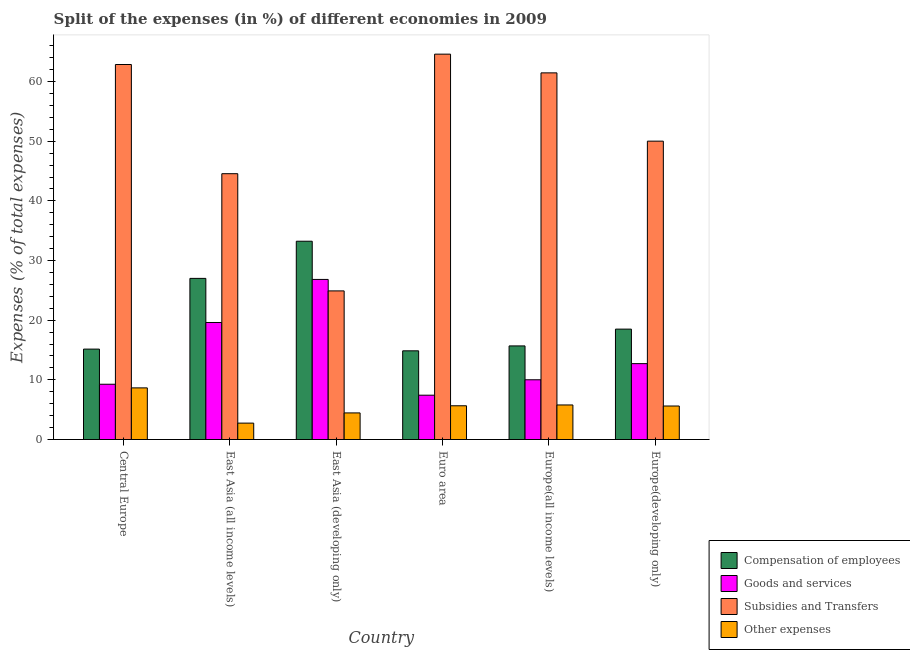How many bars are there on the 6th tick from the left?
Ensure brevity in your answer.  4. What is the label of the 4th group of bars from the left?
Provide a succinct answer. Euro area. What is the percentage of amount spent on goods and services in East Asia (all income levels)?
Your answer should be very brief. 19.62. Across all countries, what is the maximum percentage of amount spent on subsidies?
Offer a terse response. 64.59. Across all countries, what is the minimum percentage of amount spent on other expenses?
Offer a very short reply. 2.75. What is the total percentage of amount spent on other expenses in the graph?
Your response must be concise. 32.93. What is the difference between the percentage of amount spent on other expenses in Europe(all income levels) and that in Europe(developing only)?
Your answer should be very brief. 0.18. What is the difference between the percentage of amount spent on goods and services in Europe(all income levels) and the percentage of amount spent on other expenses in Europe(developing only)?
Give a very brief answer. 4.4. What is the average percentage of amount spent on subsidies per country?
Your answer should be very brief. 51.4. What is the difference between the percentage of amount spent on other expenses and percentage of amount spent on compensation of employees in East Asia (all income levels)?
Ensure brevity in your answer.  -24.26. In how many countries, is the percentage of amount spent on compensation of employees greater than 28 %?
Ensure brevity in your answer.  1. What is the ratio of the percentage of amount spent on goods and services in East Asia (all income levels) to that in Europe(developing only)?
Provide a short and direct response. 1.54. Is the percentage of amount spent on subsidies in East Asia (all income levels) less than that in Europe(developing only)?
Make the answer very short. Yes. What is the difference between the highest and the second highest percentage of amount spent on compensation of employees?
Offer a terse response. 6.23. What is the difference between the highest and the lowest percentage of amount spent on goods and services?
Your response must be concise. 19.41. In how many countries, is the percentage of amount spent on goods and services greater than the average percentage of amount spent on goods and services taken over all countries?
Offer a terse response. 2. What does the 3rd bar from the left in Central Europe represents?
Provide a succinct answer. Subsidies and Transfers. What does the 4th bar from the right in Central Europe represents?
Make the answer very short. Compensation of employees. Are all the bars in the graph horizontal?
Offer a terse response. No. How many countries are there in the graph?
Your answer should be compact. 6. What is the difference between two consecutive major ticks on the Y-axis?
Give a very brief answer. 10. Are the values on the major ticks of Y-axis written in scientific E-notation?
Offer a very short reply. No. Where does the legend appear in the graph?
Give a very brief answer. Bottom right. How many legend labels are there?
Offer a very short reply. 4. What is the title of the graph?
Provide a short and direct response. Split of the expenses (in %) of different economies in 2009. Does "Iceland" appear as one of the legend labels in the graph?
Your response must be concise. No. What is the label or title of the Y-axis?
Offer a terse response. Expenses (% of total expenses). What is the Expenses (% of total expenses) in Compensation of employees in Central Europe?
Your answer should be compact. 15.16. What is the Expenses (% of total expenses) in Goods and services in Central Europe?
Keep it short and to the point. 9.27. What is the Expenses (% of total expenses) in Subsidies and Transfers in Central Europe?
Give a very brief answer. 62.86. What is the Expenses (% of total expenses) of Other expenses in Central Europe?
Keep it short and to the point. 8.65. What is the Expenses (% of total expenses) in Compensation of employees in East Asia (all income levels)?
Provide a short and direct response. 27.01. What is the Expenses (% of total expenses) of Goods and services in East Asia (all income levels)?
Ensure brevity in your answer.  19.62. What is the Expenses (% of total expenses) of Subsidies and Transfers in East Asia (all income levels)?
Offer a very short reply. 44.56. What is the Expenses (% of total expenses) of Other expenses in East Asia (all income levels)?
Offer a terse response. 2.75. What is the Expenses (% of total expenses) of Compensation of employees in East Asia (developing only)?
Keep it short and to the point. 33.24. What is the Expenses (% of total expenses) of Goods and services in East Asia (developing only)?
Make the answer very short. 26.83. What is the Expenses (% of total expenses) of Subsidies and Transfers in East Asia (developing only)?
Keep it short and to the point. 24.91. What is the Expenses (% of total expenses) of Other expenses in East Asia (developing only)?
Ensure brevity in your answer.  4.46. What is the Expenses (% of total expenses) of Compensation of employees in Euro area?
Your response must be concise. 14.87. What is the Expenses (% of total expenses) of Goods and services in Euro area?
Offer a terse response. 7.43. What is the Expenses (% of total expenses) of Subsidies and Transfers in Euro area?
Offer a terse response. 64.59. What is the Expenses (% of total expenses) of Other expenses in Euro area?
Offer a terse response. 5.66. What is the Expenses (% of total expenses) in Compensation of employees in Europe(all income levels)?
Keep it short and to the point. 15.69. What is the Expenses (% of total expenses) in Goods and services in Europe(all income levels)?
Keep it short and to the point. 10.01. What is the Expenses (% of total expenses) in Subsidies and Transfers in Europe(all income levels)?
Offer a very short reply. 61.46. What is the Expenses (% of total expenses) in Other expenses in Europe(all income levels)?
Ensure brevity in your answer.  5.79. What is the Expenses (% of total expenses) in Compensation of employees in Europe(developing only)?
Your answer should be very brief. 18.5. What is the Expenses (% of total expenses) of Goods and services in Europe(developing only)?
Your answer should be very brief. 12.72. What is the Expenses (% of total expenses) in Subsidies and Transfers in Europe(developing only)?
Offer a terse response. 50.01. What is the Expenses (% of total expenses) of Other expenses in Europe(developing only)?
Ensure brevity in your answer.  5.62. Across all countries, what is the maximum Expenses (% of total expenses) of Compensation of employees?
Your answer should be compact. 33.24. Across all countries, what is the maximum Expenses (% of total expenses) in Goods and services?
Your answer should be very brief. 26.83. Across all countries, what is the maximum Expenses (% of total expenses) in Subsidies and Transfers?
Offer a terse response. 64.59. Across all countries, what is the maximum Expenses (% of total expenses) of Other expenses?
Provide a short and direct response. 8.65. Across all countries, what is the minimum Expenses (% of total expenses) of Compensation of employees?
Make the answer very short. 14.87. Across all countries, what is the minimum Expenses (% of total expenses) in Goods and services?
Give a very brief answer. 7.43. Across all countries, what is the minimum Expenses (% of total expenses) in Subsidies and Transfers?
Provide a short and direct response. 24.91. Across all countries, what is the minimum Expenses (% of total expenses) in Other expenses?
Give a very brief answer. 2.75. What is the total Expenses (% of total expenses) in Compensation of employees in the graph?
Your answer should be very brief. 124.46. What is the total Expenses (% of total expenses) in Goods and services in the graph?
Your response must be concise. 85.88. What is the total Expenses (% of total expenses) of Subsidies and Transfers in the graph?
Keep it short and to the point. 308.39. What is the total Expenses (% of total expenses) in Other expenses in the graph?
Give a very brief answer. 32.93. What is the difference between the Expenses (% of total expenses) in Compensation of employees in Central Europe and that in East Asia (all income levels)?
Provide a succinct answer. -11.85. What is the difference between the Expenses (% of total expenses) of Goods and services in Central Europe and that in East Asia (all income levels)?
Give a very brief answer. -10.35. What is the difference between the Expenses (% of total expenses) of Subsidies and Transfers in Central Europe and that in East Asia (all income levels)?
Ensure brevity in your answer.  18.3. What is the difference between the Expenses (% of total expenses) in Other expenses in Central Europe and that in East Asia (all income levels)?
Your response must be concise. 5.91. What is the difference between the Expenses (% of total expenses) of Compensation of employees in Central Europe and that in East Asia (developing only)?
Offer a very short reply. -18.08. What is the difference between the Expenses (% of total expenses) of Goods and services in Central Europe and that in East Asia (developing only)?
Make the answer very short. -17.57. What is the difference between the Expenses (% of total expenses) of Subsidies and Transfers in Central Europe and that in East Asia (developing only)?
Offer a terse response. 37.95. What is the difference between the Expenses (% of total expenses) in Other expenses in Central Europe and that in East Asia (developing only)?
Your response must be concise. 4.2. What is the difference between the Expenses (% of total expenses) in Compensation of employees in Central Europe and that in Euro area?
Provide a short and direct response. 0.29. What is the difference between the Expenses (% of total expenses) in Goods and services in Central Europe and that in Euro area?
Make the answer very short. 1.84. What is the difference between the Expenses (% of total expenses) in Subsidies and Transfers in Central Europe and that in Euro area?
Provide a succinct answer. -1.74. What is the difference between the Expenses (% of total expenses) of Other expenses in Central Europe and that in Euro area?
Keep it short and to the point. 3. What is the difference between the Expenses (% of total expenses) in Compensation of employees in Central Europe and that in Europe(all income levels)?
Your answer should be compact. -0.53. What is the difference between the Expenses (% of total expenses) in Goods and services in Central Europe and that in Europe(all income levels)?
Offer a very short reply. -0.75. What is the difference between the Expenses (% of total expenses) of Subsidies and Transfers in Central Europe and that in Europe(all income levels)?
Your answer should be very brief. 1.4. What is the difference between the Expenses (% of total expenses) in Other expenses in Central Europe and that in Europe(all income levels)?
Offer a terse response. 2.86. What is the difference between the Expenses (% of total expenses) of Compensation of employees in Central Europe and that in Europe(developing only)?
Ensure brevity in your answer.  -3.35. What is the difference between the Expenses (% of total expenses) of Goods and services in Central Europe and that in Europe(developing only)?
Provide a short and direct response. -3.45. What is the difference between the Expenses (% of total expenses) in Subsidies and Transfers in Central Europe and that in Europe(developing only)?
Provide a succinct answer. 12.85. What is the difference between the Expenses (% of total expenses) in Other expenses in Central Europe and that in Europe(developing only)?
Your response must be concise. 3.04. What is the difference between the Expenses (% of total expenses) of Compensation of employees in East Asia (all income levels) and that in East Asia (developing only)?
Offer a terse response. -6.23. What is the difference between the Expenses (% of total expenses) of Goods and services in East Asia (all income levels) and that in East Asia (developing only)?
Provide a succinct answer. -7.22. What is the difference between the Expenses (% of total expenses) of Subsidies and Transfers in East Asia (all income levels) and that in East Asia (developing only)?
Keep it short and to the point. 19.65. What is the difference between the Expenses (% of total expenses) in Other expenses in East Asia (all income levels) and that in East Asia (developing only)?
Make the answer very short. -1.71. What is the difference between the Expenses (% of total expenses) in Compensation of employees in East Asia (all income levels) and that in Euro area?
Give a very brief answer. 12.14. What is the difference between the Expenses (% of total expenses) of Goods and services in East Asia (all income levels) and that in Euro area?
Your answer should be compact. 12.19. What is the difference between the Expenses (% of total expenses) of Subsidies and Transfers in East Asia (all income levels) and that in Euro area?
Give a very brief answer. -20.04. What is the difference between the Expenses (% of total expenses) of Other expenses in East Asia (all income levels) and that in Euro area?
Your answer should be compact. -2.91. What is the difference between the Expenses (% of total expenses) of Compensation of employees in East Asia (all income levels) and that in Europe(all income levels)?
Offer a terse response. 11.32. What is the difference between the Expenses (% of total expenses) of Goods and services in East Asia (all income levels) and that in Europe(all income levels)?
Make the answer very short. 9.6. What is the difference between the Expenses (% of total expenses) of Subsidies and Transfers in East Asia (all income levels) and that in Europe(all income levels)?
Give a very brief answer. -16.9. What is the difference between the Expenses (% of total expenses) in Other expenses in East Asia (all income levels) and that in Europe(all income levels)?
Keep it short and to the point. -3.04. What is the difference between the Expenses (% of total expenses) of Compensation of employees in East Asia (all income levels) and that in Europe(developing only)?
Keep it short and to the point. 8.51. What is the difference between the Expenses (% of total expenses) of Goods and services in East Asia (all income levels) and that in Europe(developing only)?
Give a very brief answer. 6.9. What is the difference between the Expenses (% of total expenses) of Subsidies and Transfers in East Asia (all income levels) and that in Europe(developing only)?
Ensure brevity in your answer.  -5.45. What is the difference between the Expenses (% of total expenses) in Other expenses in East Asia (all income levels) and that in Europe(developing only)?
Ensure brevity in your answer.  -2.87. What is the difference between the Expenses (% of total expenses) of Compensation of employees in East Asia (developing only) and that in Euro area?
Offer a very short reply. 18.37. What is the difference between the Expenses (% of total expenses) of Goods and services in East Asia (developing only) and that in Euro area?
Your response must be concise. 19.41. What is the difference between the Expenses (% of total expenses) of Subsidies and Transfers in East Asia (developing only) and that in Euro area?
Your response must be concise. -39.68. What is the difference between the Expenses (% of total expenses) in Other expenses in East Asia (developing only) and that in Euro area?
Provide a succinct answer. -1.2. What is the difference between the Expenses (% of total expenses) in Compensation of employees in East Asia (developing only) and that in Europe(all income levels)?
Provide a short and direct response. 17.55. What is the difference between the Expenses (% of total expenses) in Goods and services in East Asia (developing only) and that in Europe(all income levels)?
Provide a short and direct response. 16.82. What is the difference between the Expenses (% of total expenses) in Subsidies and Transfers in East Asia (developing only) and that in Europe(all income levels)?
Give a very brief answer. -36.55. What is the difference between the Expenses (% of total expenses) of Other expenses in East Asia (developing only) and that in Europe(all income levels)?
Make the answer very short. -1.33. What is the difference between the Expenses (% of total expenses) in Compensation of employees in East Asia (developing only) and that in Europe(developing only)?
Your answer should be very brief. 14.73. What is the difference between the Expenses (% of total expenses) of Goods and services in East Asia (developing only) and that in Europe(developing only)?
Ensure brevity in your answer.  14.12. What is the difference between the Expenses (% of total expenses) of Subsidies and Transfers in East Asia (developing only) and that in Europe(developing only)?
Make the answer very short. -25.1. What is the difference between the Expenses (% of total expenses) in Other expenses in East Asia (developing only) and that in Europe(developing only)?
Provide a succinct answer. -1.16. What is the difference between the Expenses (% of total expenses) of Compensation of employees in Euro area and that in Europe(all income levels)?
Offer a very short reply. -0.82. What is the difference between the Expenses (% of total expenses) in Goods and services in Euro area and that in Europe(all income levels)?
Offer a very short reply. -2.59. What is the difference between the Expenses (% of total expenses) in Subsidies and Transfers in Euro area and that in Europe(all income levels)?
Provide a succinct answer. 3.14. What is the difference between the Expenses (% of total expenses) of Other expenses in Euro area and that in Europe(all income levels)?
Your answer should be compact. -0.14. What is the difference between the Expenses (% of total expenses) of Compensation of employees in Euro area and that in Europe(developing only)?
Offer a terse response. -3.64. What is the difference between the Expenses (% of total expenses) in Goods and services in Euro area and that in Europe(developing only)?
Your answer should be very brief. -5.29. What is the difference between the Expenses (% of total expenses) in Subsidies and Transfers in Euro area and that in Europe(developing only)?
Make the answer very short. 14.58. What is the difference between the Expenses (% of total expenses) in Other expenses in Euro area and that in Europe(developing only)?
Your answer should be very brief. 0.04. What is the difference between the Expenses (% of total expenses) in Compensation of employees in Europe(all income levels) and that in Europe(developing only)?
Provide a short and direct response. -2.81. What is the difference between the Expenses (% of total expenses) in Goods and services in Europe(all income levels) and that in Europe(developing only)?
Keep it short and to the point. -2.7. What is the difference between the Expenses (% of total expenses) of Subsidies and Transfers in Europe(all income levels) and that in Europe(developing only)?
Your response must be concise. 11.44. What is the difference between the Expenses (% of total expenses) in Other expenses in Europe(all income levels) and that in Europe(developing only)?
Provide a succinct answer. 0.18. What is the difference between the Expenses (% of total expenses) in Compensation of employees in Central Europe and the Expenses (% of total expenses) in Goods and services in East Asia (all income levels)?
Make the answer very short. -4.46. What is the difference between the Expenses (% of total expenses) of Compensation of employees in Central Europe and the Expenses (% of total expenses) of Subsidies and Transfers in East Asia (all income levels)?
Give a very brief answer. -29.4. What is the difference between the Expenses (% of total expenses) of Compensation of employees in Central Europe and the Expenses (% of total expenses) of Other expenses in East Asia (all income levels)?
Ensure brevity in your answer.  12.41. What is the difference between the Expenses (% of total expenses) of Goods and services in Central Europe and the Expenses (% of total expenses) of Subsidies and Transfers in East Asia (all income levels)?
Your response must be concise. -35.29. What is the difference between the Expenses (% of total expenses) of Goods and services in Central Europe and the Expenses (% of total expenses) of Other expenses in East Asia (all income levels)?
Offer a very short reply. 6.52. What is the difference between the Expenses (% of total expenses) of Subsidies and Transfers in Central Europe and the Expenses (% of total expenses) of Other expenses in East Asia (all income levels)?
Ensure brevity in your answer.  60.11. What is the difference between the Expenses (% of total expenses) of Compensation of employees in Central Europe and the Expenses (% of total expenses) of Goods and services in East Asia (developing only)?
Your answer should be compact. -11.68. What is the difference between the Expenses (% of total expenses) in Compensation of employees in Central Europe and the Expenses (% of total expenses) in Subsidies and Transfers in East Asia (developing only)?
Provide a short and direct response. -9.75. What is the difference between the Expenses (% of total expenses) of Compensation of employees in Central Europe and the Expenses (% of total expenses) of Other expenses in East Asia (developing only)?
Provide a short and direct response. 10.7. What is the difference between the Expenses (% of total expenses) in Goods and services in Central Europe and the Expenses (% of total expenses) in Subsidies and Transfers in East Asia (developing only)?
Provide a succinct answer. -15.64. What is the difference between the Expenses (% of total expenses) in Goods and services in Central Europe and the Expenses (% of total expenses) in Other expenses in East Asia (developing only)?
Offer a very short reply. 4.81. What is the difference between the Expenses (% of total expenses) in Subsidies and Transfers in Central Europe and the Expenses (% of total expenses) in Other expenses in East Asia (developing only)?
Your answer should be compact. 58.4. What is the difference between the Expenses (% of total expenses) of Compensation of employees in Central Europe and the Expenses (% of total expenses) of Goods and services in Euro area?
Provide a short and direct response. 7.73. What is the difference between the Expenses (% of total expenses) in Compensation of employees in Central Europe and the Expenses (% of total expenses) in Subsidies and Transfers in Euro area?
Give a very brief answer. -49.44. What is the difference between the Expenses (% of total expenses) in Compensation of employees in Central Europe and the Expenses (% of total expenses) in Other expenses in Euro area?
Your response must be concise. 9.5. What is the difference between the Expenses (% of total expenses) in Goods and services in Central Europe and the Expenses (% of total expenses) in Subsidies and Transfers in Euro area?
Your answer should be compact. -55.33. What is the difference between the Expenses (% of total expenses) in Goods and services in Central Europe and the Expenses (% of total expenses) in Other expenses in Euro area?
Your answer should be very brief. 3.61. What is the difference between the Expenses (% of total expenses) of Subsidies and Transfers in Central Europe and the Expenses (% of total expenses) of Other expenses in Euro area?
Provide a short and direct response. 57.2. What is the difference between the Expenses (% of total expenses) in Compensation of employees in Central Europe and the Expenses (% of total expenses) in Goods and services in Europe(all income levels)?
Give a very brief answer. 5.14. What is the difference between the Expenses (% of total expenses) of Compensation of employees in Central Europe and the Expenses (% of total expenses) of Subsidies and Transfers in Europe(all income levels)?
Give a very brief answer. -46.3. What is the difference between the Expenses (% of total expenses) of Compensation of employees in Central Europe and the Expenses (% of total expenses) of Other expenses in Europe(all income levels)?
Ensure brevity in your answer.  9.36. What is the difference between the Expenses (% of total expenses) in Goods and services in Central Europe and the Expenses (% of total expenses) in Subsidies and Transfers in Europe(all income levels)?
Offer a very short reply. -52.19. What is the difference between the Expenses (% of total expenses) in Goods and services in Central Europe and the Expenses (% of total expenses) in Other expenses in Europe(all income levels)?
Your answer should be very brief. 3.47. What is the difference between the Expenses (% of total expenses) in Subsidies and Transfers in Central Europe and the Expenses (% of total expenses) in Other expenses in Europe(all income levels)?
Offer a terse response. 57.06. What is the difference between the Expenses (% of total expenses) in Compensation of employees in Central Europe and the Expenses (% of total expenses) in Goods and services in Europe(developing only)?
Keep it short and to the point. 2.44. What is the difference between the Expenses (% of total expenses) in Compensation of employees in Central Europe and the Expenses (% of total expenses) in Subsidies and Transfers in Europe(developing only)?
Provide a succinct answer. -34.86. What is the difference between the Expenses (% of total expenses) of Compensation of employees in Central Europe and the Expenses (% of total expenses) of Other expenses in Europe(developing only)?
Offer a very short reply. 9.54. What is the difference between the Expenses (% of total expenses) of Goods and services in Central Europe and the Expenses (% of total expenses) of Subsidies and Transfers in Europe(developing only)?
Provide a succinct answer. -40.74. What is the difference between the Expenses (% of total expenses) in Goods and services in Central Europe and the Expenses (% of total expenses) in Other expenses in Europe(developing only)?
Offer a terse response. 3.65. What is the difference between the Expenses (% of total expenses) of Subsidies and Transfers in Central Europe and the Expenses (% of total expenses) of Other expenses in Europe(developing only)?
Offer a terse response. 57.24. What is the difference between the Expenses (% of total expenses) of Compensation of employees in East Asia (all income levels) and the Expenses (% of total expenses) of Goods and services in East Asia (developing only)?
Make the answer very short. 0.17. What is the difference between the Expenses (% of total expenses) in Compensation of employees in East Asia (all income levels) and the Expenses (% of total expenses) in Subsidies and Transfers in East Asia (developing only)?
Your answer should be very brief. 2.1. What is the difference between the Expenses (% of total expenses) in Compensation of employees in East Asia (all income levels) and the Expenses (% of total expenses) in Other expenses in East Asia (developing only)?
Offer a terse response. 22.55. What is the difference between the Expenses (% of total expenses) in Goods and services in East Asia (all income levels) and the Expenses (% of total expenses) in Subsidies and Transfers in East Asia (developing only)?
Provide a short and direct response. -5.29. What is the difference between the Expenses (% of total expenses) in Goods and services in East Asia (all income levels) and the Expenses (% of total expenses) in Other expenses in East Asia (developing only)?
Offer a terse response. 15.16. What is the difference between the Expenses (% of total expenses) of Subsidies and Transfers in East Asia (all income levels) and the Expenses (% of total expenses) of Other expenses in East Asia (developing only)?
Offer a terse response. 40.1. What is the difference between the Expenses (% of total expenses) of Compensation of employees in East Asia (all income levels) and the Expenses (% of total expenses) of Goods and services in Euro area?
Offer a very short reply. 19.58. What is the difference between the Expenses (% of total expenses) of Compensation of employees in East Asia (all income levels) and the Expenses (% of total expenses) of Subsidies and Transfers in Euro area?
Keep it short and to the point. -37.58. What is the difference between the Expenses (% of total expenses) of Compensation of employees in East Asia (all income levels) and the Expenses (% of total expenses) of Other expenses in Euro area?
Keep it short and to the point. 21.35. What is the difference between the Expenses (% of total expenses) of Goods and services in East Asia (all income levels) and the Expenses (% of total expenses) of Subsidies and Transfers in Euro area?
Provide a short and direct response. -44.98. What is the difference between the Expenses (% of total expenses) in Goods and services in East Asia (all income levels) and the Expenses (% of total expenses) in Other expenses in Euro area?
Provide a succinct answer. 13.96. What is the difference between the Expenses (% of total expenses) in Subsidies and Transfers in East Asia (all income levels) and the Expenses (% of total expenses) in Other expenses in Euro area?
Provide a short and direct response. 38.9. What is the difference between the Expenses (% of total expenses) of Compensation of employees in East Asia (all income levels) and the Expenses (% of total expenses) of Goods and services in Europe(all income levels)?
Give a very brief answer. 16.99. What is the difference between the Expenses (% of total expenses) in Compensation of employees in East Asia (all income levels) and the Expenses (% of total expenses) in Subsidies and Transfers in Europe(all income levels)?
Offer a terse response. -34.45. What is the difference between the Expenses (% of total expenses) in Compensation of employees in East Asia (all income levels) and the Expenses (% of total expenses) in Other expenses in Europe(all income levels)?
Your answer should be very brief. 21.22. What is the difference between the Expenses (% of total expenses) in Goods and services in East Asia (all income levels) and the Expenses (% of total expenses) in Subsidies and Transfers in Europe(all income levels)?
Make the answer very short. -41.84. What is the difference between the Expenses (% of total expenses) of Goods and services in East Asia (all income levels) and the Expenses (% of total expenses) of Other expenses in Europe(all income levels)?
Keep it short and to the point. 13.82. What is the difference between the Expenses (% of total expenses) of Subsidies and Transfers in East Asia (all income levels) and the Expenses (% of total expenses) of Other expenses in Europe(all income levels)?
Your answer should be compact. 38.76. What is the difference between the Expenses (% of total expenses) of Compensation of employees in East Asia (all income levels) and the Expenses (% of total expenses) of Goods and services in Europe(developing only)?
Your answer should be compact. 14.29. What is the difference between the Expenses (% of total expenses) of Compensation of employees in East Asia (all income levels) and the Expenses (% of total expenses) of Subsidies and Transfers in Europe(developing only)?
Your answer should be very brief. -23. What is the difference between the Expenses (% of total expenses) in Compensation of employees in East Asia (all income levels) and the Expenses (% of total expenses) in Other expenses in Europe(developing only)?
Provide a short and direct response. 21.39. What is the difference between the Expenses (% of total expenses) in Goods and services in East Asia (all income levels) and the Expenses (% of total expenses) in Subsidies and Transfers in Europe(developing only)?
Offer a terse response. -30.4. What is the difference between the Expenses (% of total expenses) in Goods and services in East Asia (all income levels) and the Expenses (% of total expenses) in Other expenses in Europe(developing only)?
Offer a terse response. 14. What is the difference between the Expenses (% of total expenses) of Subsidies and Transfers in East Asia (all income levels) and the Expenses (% of total expenses) of Other expenses in Europe(developing only)?
Give a very brief answer. 38.94. What is the difference between the Expenses (% of total expenses) of Compensation of employees in East Asia (developing only) and the Expenses (% of total expenses) of Goods and services in Euro area?
Provide a succinct answer. 25.81. What is the difference between the Expenses (% of total expenses) in Compensation of employees in East Asia (developing only) and the Expenses (% of total expenses) in Subsidies and Transfers in Euro area?
Give a very brief answer. -31.36. What is the difference between the Expenses (% of total expenses) of Compensation of employees in East Asia (developing only) and the Expenses (% of total expenses) of Other expenses in Euro area?
Your answer should be very brief. 27.58. What is the difference between the Expenses (% of total expenses) in Goods and services in East Asia (developing only) and the Expenses (% of total expenses) in Subsidies and Transfers in Euro area?
Your response must be concise. -37.76. What is the difference between the Expenses (% of total expenses) of Goods and services in East Asia (developing only) and the Expenses (% of total expenses) of Other expenses in Euro area?
Provide a succinct answer. 21.18. What is the difference between the Expenses (% of total expenses) in Subsidies and Transfers in East Asia (developing only) and the Expenses (% of total expenses) in Other expenses in Euro area?
Ensure brevity in your answer.  19.25. What is the difference between the Expenses (% of total expenses) of Compensation of employees in East Asia (developing only) and the Expenses (% of total expenses) of Goods and services in Europe(all income levels)?
Offer a very short reply. 23.22. What is the difference between the Expenses (% of total expenses) in Compensation of employees in East Asia (developing only) and the Expenses (% of total expenses) in Subsidies and Transfers in Europe(all income levels)?
Provide a short and direct response. -28.22. What is the difference between the Expenses (% of total expenses) in Compensation of employees in East Asia (developing only) and the Expenses (% of total expenses) in Other expenses in Europe(all income levels)?
Your answer should be compact. 27.44. What is the difference between the Expenses (% of total expenses) of Goods and services in East Asia (developing only) and the Expenses (% of total expenses) of Subsidies and Transfers in Europe(all income levels)?
Give a very brief answer. -34.62. What is the difference between the Expenses (% of total expenses) in Goods and services in East Asia (developing only) and the Expenses (% of total expenses) in Other expenses in Europe(all income levels)?
Keep it short and to the point. 21.04. What is the difference between the Expenses (% of total expenses) of Subsidies and Transfers in East Asia (developing only) and the Expenses (% of total expenses) of Other expenses in Europe(all income levels)?
Keep it short and to the point. 19.12. What is the difference between the Expenses (% of total expenses) in Compensation of employees in East Asia (developing only) and the Expenses (% of total expenses) in Goods and services in Europe(developing only)?
Ensure brevity in your answer.  20.52. What is the difference between the Expenses (% of total expenses) of Compensation of employees in East Asia (developing only) and the Expenses (% of total expenses) of Subsidies and Transfers in Europe(developing only)?
Your answer should be very brief. -16.78. What is the difference between the Expenses (% of total expenses) of Compensation of employees in East Asia (developing only) and the Expenses (% of total expenses) of Other expenses in Europe(developing only)?
Ensure brevity in your answer.  27.62. What is the difference between the Expenses (% of total expenses) in Goods and services in East Asia (developing only) and the Expenses (% of total expenses) in Subsidies and Transfers in Europe(developing only)?
Provide a short and direct response. -23.18. What is the difference between the Expenses (% of total expenses) of Goods and services in East Asia (developing only) and the Expenses (% of total expenses) of Other expenses in Europe(developing only)?
Your response must be concise. 21.22. What is the difference between the Expenses (% of total expenses) in Subsidies and Transfers in East Asia (developing only) and the Expenses (% of total expenses) in Other expenses in Europe(developing only)?
Offer a terse response. 19.29. What is the difference between the Expenses (% of total expenses) in Compensation of employees in Euro area and the Expenses (% of total expenses) in Goods and services in Europe(all income levels)?
Give a very brief answer. 4.85. What is the difference between the Expenses (% of total expenses) in Compensation of employees in Euro area and the Expenses (% of total expenses) in Subsidies and Transfers in Europe(all income levels)?
Ensure brevity in your answer.  -46.59. What is the difference between the Expenses (% of total expenses) of Compensation of employees in Euro area and the Expenses (% of total expenses) of Other expenses in Europe(all income levels)?
Your answer should be compact. 9.07. What is the difference between the Expenses (% of total expenses) in Goods and services in Euro area and the Expenses (% of total expenses) in Subsidies and Transfers in Europe(all income levels)?
Make the answer very short. -54.03. What is the difference between the Expenses (% of total expenses) in Goods and services in Euro area and the Expenses (% of total expenses) in Other expenses in Europe(all income levels)?
Offer a terse response. 1.64. What is the difference between the Expenses (% of total expenses) in Subsidies and Transfers in Euro area and the Expenses (% of total expenses) in Other expenses in Europe(all income levels)?
Your answer should be compact. 58.8. What is the difference between the Expenses (% of total expenses) in Compensation of employees in Euro area and the Expenses (% of total expenses) in Goods and services in Europe(developing only)?
Your response must be concise. 2.15. What is the difference between the Expenses (% of total expenses) in Compensation of employees in Euro area and the Expenses (% of total expenses) in Subsidies and Transfers in Europe(developing only)?
Your response must be concise. -35.14. What is the difference between the Expenses (% of total expenses) in Compensation of employees in Euro area and the Expenses (% of total expenses) in Other expenses in Europe(developing only)?
Your answer should be compact. 9.25. What is the difference between the Expenses (% of total expenses) of Goods and services in Euro area and the Expenses (% of total expenses) of Subsidies and Transfers in Europe(developing only)?
Make the answer very short. -42.58. What is the difference between the Expenses (% of total expenses) of Goods and services in Euro area and the Expenses (% of total expenses) of Other expenses in Europe(developing only)?
Make the answer very short. 1.81. What is the difference between the Expenses (% of total expenses) of Subsidies and Transfers in Euro area and the Expenses (% of total expenses) of Other expenses in Europe(developing only)?
Your answer should be very brief. 58.98. What is the difference between the Expenses (% of total expenses) in Compensation of employees in Europe(all income levels) and the Expenses (% of total expenses) in Goods and services in Europe(developing only)?
Your answer should be very brief. 2.97. What is the difference between the Expenses (% of total expenses) of Compensation of employees in Europe(all income levels) and the Expenses (% of total expenses) of Subsidies and Transfers in Europe(developing only)?
Your response must be concise. -34.32. What is the difference between the Expenses (% of total expenses) of Compensation of employees in Europe(all income levels) and the Expenses (% of total expenses) of Other expenses in Europe(developing only)?
Make the answer very short. 10.07. What is the difference between the Expenses (% of total expenses) of Goods and services in Europe(all income levels) and the Expenses (% of total expenses) of Subsidies and Transfers in Europe(developing only)?
Make the answer very short. -40. What is the difference between the Expenses (% of total expenses) in Goods and services in Europe(all income levels) and the Expenses (% of total expenses) in Other expenses in Europe(developing only)?
Ensure brevity in your answer.  4.4. What is the difference between the Expenses (% of total expenses) of Subsidies and Transfers in Europe(all income levels) and the Expenses (% of total expenses) of Other expenses in Europe(developing only)?
Give a very brief answer. 55.84. What is the average Expenses (% of total expenses) of Compensation of employees per country?
Offer a terse response. 20.74. What is the average Expenses (% of total expenses) in Goods and services per country?
Your answer should be very brief. 14.31. What is the average Expenses (% of total expenses) in Subsidies and Transfers per country?
Provide a succinct answer. 51.4. What is the average Expenses (% of total expenses) of Other expenses per country?
Give a very brief answer. 5.49. What is the difference between the Expenses (% of total expenses) of Compensation of employees and Expenses (% of total expenses) of Goods and services in Central Europe?
Your response must be concise. 5.89. What is the difference between the Expenses (% of total expenses) in Compensation of employees and Expenses (% of total expenses) in Subsidies and Transfers in Central Europe?
Your answer should be very brief. -47.7. What is the difference between the Expenses (% of total expenses) of Compensation of employees and Expenses (% of total expenses) of Other expenses in Central Europe?
Your response must be concise. 6.5. What is the difference between the Expenses (% of total expenses) of Goods and services and Expenses (% of total expenses) of Subsidies and Transfers in Central Europe?
Keep it short and to the point. -53.59. What is the difference between the Expenses (% of total expenses) in Goods and services and Expenses (% of total expenses) in Other expenses in Central Europe?
Your answer should be compact. 0.61. What is the difference between the Expenses (% of total expenses) in Subsidies and Transfers and Expenses (% of total expenses) in Other expenses in Central Europe?
Offer a terse response. 54.2. What is the difference between the Expenses (% of total expenses) in Compensation of employees and Expenses (% of total expenses) in Goods and services in East Asia (all income levels)?
Your answer should be compact. 7.39. What is the difference between the Expenses (% of total expenses) in Compensation of employees and Expenses (% of total expenses) in Subsidies and Transfers in East Asia (all income levels)?
Provide a succinct answer. -17.55. What is the difference between the Expenses (% of total expenses) in Compensation of employees and Expenses (% of total expenses) in Other expenses in East Asia (all income levels)?
Your response must be concise. 24.26. What is the difference between the Expenses (% of total expenses) of Goods and services and Expenses (% of total expenses) of Subsidies and Transfers in East Asia (all income levels)?
Ensure brevity in your answer.  -24.94. What is the difference between the Expenses (% of total expenses) of Goods and services and Expenses (% of total expenses) of Other expenses in East Asia (all income levels)?
Provide a short and direct response. 16.87. What is the difference between the Expenses (% of total expenses) of Subsidies and Transfers and Expenses (% of total expenses) of Other expenses in East Asia (all income levels)?
Provide a succinct answer. 41.81. What is the difference between the Expenses (% of total expenses) in Compensation of employees and Expenses (% of total expenses) in Goods and services in East Asia (developing only)?
Offer a terse response. 6.4. What is the difference between the Expenses (% of total expenses) in Compensation of employees and Expenses (% of total expenses) in Subsidies and Transfers in East Asia (developing only)?
Your response must be concise. 8.33. What is the difference between the Expenses (% of total expenses) of Compensation of employees and Expenses (% of total expenses) of Other expenses in East Asia (developing only)?
Keep it short and to the point. 28.78. What is the difference between the Expenses (% of total expenses) of Goods and services and Expenses (% of total expenses) of Subsidies and Transfers in East Asia (developing only)?
Keep it short and to the point. 1.92. What is the difference between the Expenses (% of total expenses) in Goods and services and Expenses (% of total expenses) in Other expenses in East Asia (developing only)?
Make the answer very short. 22.38. What is the difference between the Expenses (% of total expenses) of Subsidies and Transfers and Expenses (% of total expenses) of Other expenses in East Asia (developing only)?
Keep it short and to the point. 20.45. What is the difference between the Expenses (% of total expenses) of Compensation of employees and Expenses (% of total expenses) of Goods and services in Euro area?
Give a very brief answer. 7.44. What is the difference between the Expenses (% of total expenses) in Compensation of employees and Expenses (% of total expenses) in Subsidies and Transfers in Euro area?
Your response must be concise. -49.73. What is the difference between the Expenses (% of total expenses) in Compensation of employees and Expenses (% of total expenses) in Other expenses in Euro area?
Offer a terse response. 9.21. What is the difference between the Expenses (% of total expenses) in Goods and services and Expenses (% of total expenses) in Subsidies and Transfers in Euro area?
Offer a terse response. -57.17. What is the difference between the Expenses (% of total expenses) of Goods and services and Expenses (% of total expenses) of Other expenses in Euro area?
Keep it short and to the point. 1.77. What is the difference between the Expenses (% of total expenses) in Subsidies and Transfers and Expenses (% of total expenses) in Other expenses in Euro area?
Your response must be concise. 58.94. What is the difference between the Expenses (% of total expenses) of Compensation of employees and Expenses (% of total expenses) of Goods and services in Europe(all income levels)?
Give a very brief answer. 5.68. What is the difference between the Expenses (% of total expenses) of Compensation of employees and Expenses (% of total expenses) of Subsidies and Transfers in Europe(all income levels)?
Your answer should be compact. -45.77. What is the difference between the Expenses (% of total expenses) in Compensation of employees and Expenses (% of total expenses) in Other expenses in Europe(all income levels)?
Give a very brief answer. 9.9. What is the difference between the Expenses (% of total expenses) in Goods and services and Expenses (% of total expenses) in Subsidies and Transfers in Europe(all income levels)?
Your answer should be compact. -51.44. What is the difference between the Expenses (% of total expenses) in Goods and services and Expenses (% of total expenses) in Other expenses in Europe(all income levels)?
Make the answer very short. 4.22. What is the difference between the Expenses (% of total expenses) of Subsidies and Transfers and Expenses (% of total expenses) of Other expenses in Europe(all income levels)?
Keep it short and to the point. 55.66. What is the difference between the Expenses (% of total expenses) of Compensation of employees and Expenses (% of total expenses) of Goods and services in Europe(developing only)?
Provide a succinct answer. 5.79. What is the difference between the Expenses (% of total expenses) in Compensation of employees and Expenses (% of total expenses) in Subsidies and Transfers in Europe(developing only)?
Provide a succinct answer. -31.51. What is the difference between the Expenses (% of total expenses) in Compensation of employees and Expenses (% of total expenses) in Other expenses in Europe(developing only)?
Provide a succinct answer. 12.89. What is the difference between the Expenses (% of total expenses) of Goods and services and Expenses (% of total expenses) of Subsidies and Transfers in Europe(developing only)?
Offer a very short reply. -37.29. What is the difference between the Expenses (% of total expenses) in Goods and services and Expenses (% of total expenses) in Other expenses in Europe(developing only)?
Make the answer very short. 7.1. What is the difference between the Expenses (% of total expenses) of Subsidies and Transfers and Expenses (% of total expenses) of Other expenses in Europe(developing only)?
Provide a succinct answer. 44.39. What is the ratio of the Expenses (% of total expenses) in Compensation of employees in Central Europe to that in East Asia (all income levels)?
Make the answer very short. 0.56. What is the ratio of the Expenses (% of total expenses) in Goods and services in Central Europe to that in East Asia (all income levels)?
Give a very brief answer. 0.47. What is the ratio of the Expenses (% of total expenses) in Subsidies and Transfers in Central Europe to that in East Asia (all income levels)?
Give a very brief answer. 1.41. What is the ratio of the Expenses (% of total expenses) in Other expenses in Central Europe to that in East Asia (all income levels)?
Make the answer very short. 3.15. What is the ratio of the Expenses (% of total expenses) in Compensation of employees in Central Europe to that in East Asia (developing only)?
Keep it short and to the point. 0.46. What is the ratio of the Expenses (% of total expenses) in Goods and services in Central Europe to that in East Asia (developing only)?
Your answer should be compact. 0.35. What is the ratio of the Expenses (% of total expenses) in Subsidies and Transfers in Central Europe to that in East Asia (developing only)?
Offer a very short reply. 2.52. What is the ratio of the Expenses (% of total expenses) in Other expenses in Central Europe to that in East Asia (developing only)?
Make the answer very short. 1.94. What is the ratio of the Expenses (% of total expenses) of Compensation of employees in Central Europe to that in Euro area?
Make the answer very short. 1.02. What is the ratio of the Expenses (% of total expenses) of Goods and services in Central Europe to that in Euro area?
Keep it short and to the point. 1.25. What is the ratio of the Expenses (% of total expenses) of Subsidies and Transfers in Central Europe to that in Euro area?
Your answer should be compact. 0.97. What is the ratio of the Expenses (% of total expenses) of Other expenses in Central Europe to that in Euro area?
Offer a terse response. 1.53. What is the ratio of the Expenses (% of total expenses) of Compensation of employees in Central Europe to that in Europe(all income levels)?
Provide a short and direct response. 0.97. What is the ratio of the Expenses (% of total expenses) of Goods and services in Central Europe to that in Europe(all income levels)?
Offer a very short reply. 0.93. What is the ratio of the Expenses (% of total expenses) of Subsidies and Transfers in Central Europe to that in Europe(all income levels)?
Your response must be concise. 1.02. What is the ratio of the Expenses (% of total expenses) in Other expenses in Central Europe to that in Europe(all income levels)?
Provide a succinct answer. 1.49. What is the ratio of the Expenses (% of total expenses) of Compensation of employees in Central Europe to that in Europe(developing only)?
Make the answer very short. 0.82. What is the ratio of the Expenses (% of total expenses) in Goods and services in Central Europe to that in Europe(developing only)?
Your response must be concise. 0.73. What is the ratio of the Expenses (% of total expenses) in Subsidies and Transfers in Central Europe to that in Europe(developing only)?
Provide a short and direct response. 1.26. What is the ratio of the Expenses (% of total expenses) in Other expenses in Central Europe to that in Europe(developing only)?
Ensure brevity in your answer.  1.54. What is the ratio of the Expenses (% of total expenses) of Compensation of employees in East Asia (all income levels) to that in East Asia (developing only)?
Your answer should be very brief. 0.81. What is the ratio of the Expenses (% of total expenses) in Goods and services in East Asia (all income levels) to that in East Asia (developing only)?
Provide a short and direct response. 0.73. What is the ratio of the Expenses (% of total expenses) of Subsidies and Transfers in East Asia (all income levels) to that in East Asia (developing only)?
Provide a succinct answer. 1.79. What is the ratio of the Expenses (% of total expenses) of Other expenses in East Asia (all income levels) to that in East Asia (developing only)?
Provide a succinct answer. 0.62. What is the ratio of the Expenses (% of total expenses) of Compensation of employees in East Asia (all income levels) to that in Euro area?
Your answer should be very brief. 1.82. What is the ratio of the Expenses (% of total expenses) of Goods and services in East Asia (all income levels) to that in Euro area?
Offer a terse response. 2.64. What is the ratio of the Expenses (% of total expenses) in Subsidies and Transfers in East Asia (all income levels) to that in Euro area?
Provide a short and direct response. 0.69. What is the ratio of the Expenses (% of total expenses) of Other expenses in East Asia (all income levels) to that in Euro area?
Your answer should be very brief. 0.49. What is the ratio of the Expenses (% of total expenses) in Compensation of employees in East Asia (all income levels) to that in Europe(all income levels)?
Provide a short and direct response. 1.72. What is the ratio of the Expenses (% of total expenses) of Goods and services in East Asia (all income levels) to that in Europe(all income levels)?
Keep it short and to the point. 1.96. What is the ratio of the Expenses (% of total expenses) in Subsidies and Transfers in East Asia (all income levels) to that in Europe(all income levels)?
Offer a terse response. 0.72. What is the ratio of the Expenses (% of total expenses) of Other expenses in East Asia (all income levels) to that in Europe(all income levels)?
Provide a succinct answer. 0.47. What is the ratio of the Expenses (% of total expenses) in Compensation of employees in East Asia (all income levels) to that in Europe(developing only)?
Your answer should be compact. 1.46. What is the ratio of the Expenses (% of total expenses) of Goods and services in East Asia (all income levels) to that in Europe(developing only)?
Your response must be concise. 1.54. What is the ratio of the Expenses (% of total expenses) of Subsidies and Transfers in East Asia (all income levels) to that in Europe(developing only)?
Provide a short and direct response. 0.89. What is the ratio of the Expenses (% of total expenses) of Other expenses in East Asia (all income levels) to that in Europe(developing only)?
Ensure brevity in your answer.  0.49. What is the ratio of the Expenses (% of total expenses) of Compensation of employees in East Asia (developing only) to that in Euro area?
Ensure brevity in your answer.  2.24. What is the ratio of the Expenses (% of total expenses) in Goods and services in East Asia (developing only) to that in Euro area?
Your answer should be very brief. 3.61. What is the ratio of the Expenses (% of total expenses) of Subsidies and Transfers in East Asia (developing only) to that in Euro area?
Your answer should be very brief. 0.39. What is the ratio of the Expenses (% of total expenses) of Other expenses in East Asia (developing only) to that in Euro area?
Your answer should be compact. 0.79. What is the ratio of the Expenses (% of total expenses) in Compensation of employees in East Asia (developing only) to that in Europe(all income levels)?
Your answer should be very brief. 2.12. What is the ratio of the Expenses (% of total expenses) in Goods and services in East Asia (developing only) to that in Europe(all income levels)?
Make the answer very short. 2.68. What is the ratio of the Expenses (% of total expenses) in Subsidies and Transfers in East Asia (developing only) to that in Europe(all income levels)?
Your response must be concise. 0.41. What is the ratio of the Expenses (% of total expenses) in Other expenses in East Asia (developing only) to that in Europe(all income levels)?
Provide a succinct answer. 0.77. What is the ratio of the Expenses (% of total expenses) in Compensation of employees in East Asia (developing only) to that in Europe(developing only)?
Make the answer very short. 1.8. What is the ratio of the Expenses (% of total expenses) of Goods and services in East Asia (developing only) to that in Europe(developing only)?
Make the answer very short. 2.11. What is the ratio of the Expenses (% of total expenses) of Subsidies and Transfers in East Asia (developing only) to that in Europe(developing only)?
Your answer should be compact. 0.5. What is the ratio of the Expenses (% of total expenses) of Other expenses in East Asia (developing only) to that in Europe(developing only)?
Your answer should be compact. 0.79. What is the ratio of the Expenses (% of total expenses) in Compensation of employees in Euro area to that in Europe(all income levels)?
Ensure brevity in your answer.  0.95. What is the ratio of the Expenses (% of total expenses) in Goods and services in Euro area to that in Europe(all income levels)?
Your response must be concise. 0.74. What is the ratio of the Expenses (% of total expenses) of Subsidies and Transfers in Euro area to that in Europe(all income levels)?
Keep it short and to the point. 1.05. What is the ratio of the Expenses (% of total expenses) of Other expenses in Euro area to that in Europe(all income levels)?
Your answer should be very brief. 0.98. What is the ratio of the Expenses (% of total expenses) of Compensation of employees in Euro area to that in Europe(developing only)?
Keep it short and to the point. 0.8. What is the ratio of the Expenses (% of total expenses) in Goods and services in Euro area to that in Europe(developing only)?
Give a very brief answer. 0.58. What is the ratio of the Expenses (% of total expenses) in Subsidies and Transfers in Euro area to that in Europe(developing only)?
Offer a terse response. 1.29. What is the ratio of the Expenses (% of total expenses) in Other expenses in Euro area to that in Europe(developing only)?
Your response must be concise. 1.01. What is the ratio of the Expenses (% of total expenses) in Compensation of employees in Europe(all income levels) to that in Europe(developing only)?
Provide a short and direct response. 0.85. What is the ratio of the Expenses (% of total expenses) of Goods and services in Europe(all income levels) to that in Europe(developing only)?
Provide a short and direct response. 0.79. What is the ratio of the Expenses (% of total expenses) in Subsidies and Transfers in Europe(all income levels) to that in Europe(developing only)?
Give a very brief answer. 1.23. What is the ratio of the Expenses (% of total expenses) of Other expenses in Europe(all income levels) to that in Europe(developing only)?
Offer a terse response. 1.03. What is the difference between the highest and the second highest Expenses (% of total expenses) of Compensation of employees?
Offer a very short reply. 6.23. What is the difference between the highest and the second highest Expenses (% of total expenses) of Goods and services?
Give a very brief answer. 7.22. What is the difference between the highest and the second highest Expenses (% of total expenses) of Subsidies and Transfers?
Provide a short and direct response. 1.74. What is the difference between the highest and the second highest Expenses (% of total expenses) of Other expenses?
Provide a succinct answer. 2.86. What is the difference between the highest and the lowest Expenses (% of total expenses) of Compensation of employees?
Give a very brief answer. 18.37. What is the difference between the highest and the lowest Expenses (% of total expenses) in Goods and services?
Your answer should be compact. 19.41. What is the difference between the highest and the lowest Expenses (% of total expenses) of Subsidies and Transfers?
Offer a very short reply. 39.68. What is the difference between the highest and the lowest Expenses (% of total expenses) of Other expenses?
Your answer should be compact. 5.91. 